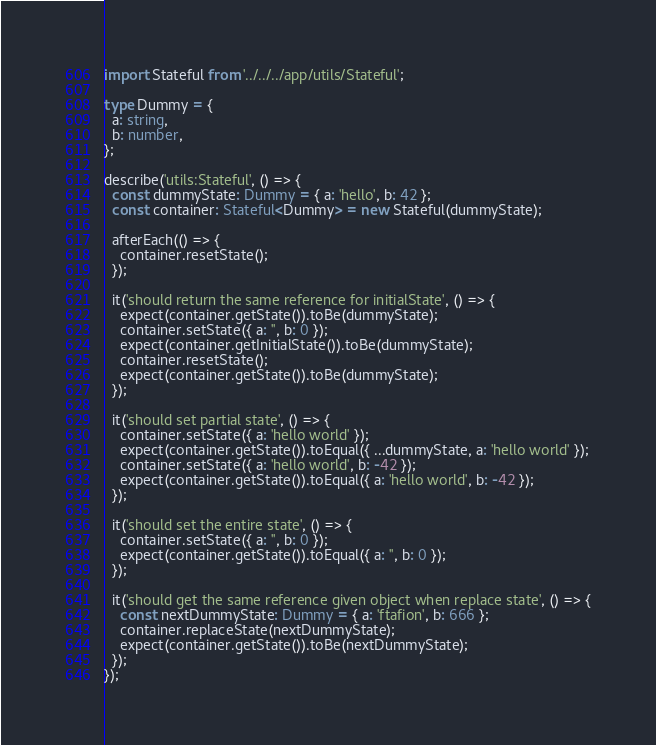<code> <loc_0><loc_0><loc_500><loc_500><_TypeScript_>import Stateful from '../../../app/utils/Stateful';

type Dummy = {
  a: string,
  b: number,
};

describe('utils:Stateful', () => {
  const dummyState: Dummy = { a: 'hello', b: 42 };
  const container: Stateful<Dummy> = new Stateful(dummyState);

  afterEach(() => {
    container.resetState();
  });

  it('should return the same reference for initialState', () => {
    expect(container.getState()).toBe(dummyState);
    container.setState({ a: '', b: 0 });
    expect(container.getInitialState()).toBe(dummyState);
    container.resetState();
    expect(container.getState()).toBe(dummyState);
  });

  it('should set partial state', () => {
    container.setState({ a: 'hello world' });
    expect(container.getState()).toEqual({ ...dummyState, a: 'hello world' });
    container.setState({ a: 'hello world', b: -42 });
    expect(container.getState()).toEqual({ a: 'hello world', b: -42 });
  });

  it('should set the entire state', () => {
    container.setState({ a: '', b: 0 });
    expect(container.getState()).toEqual({ a: '', b: 0 });
  });

  it('should get the same reference given object when replace state', () => {
    const nextDummyState: Dummy = { a: 'ftafion', b: 666 };
    container.replaceState(nextDummyState);
    expect(container.getState()).toBe(nextDummyState);
  });
});
</code> 